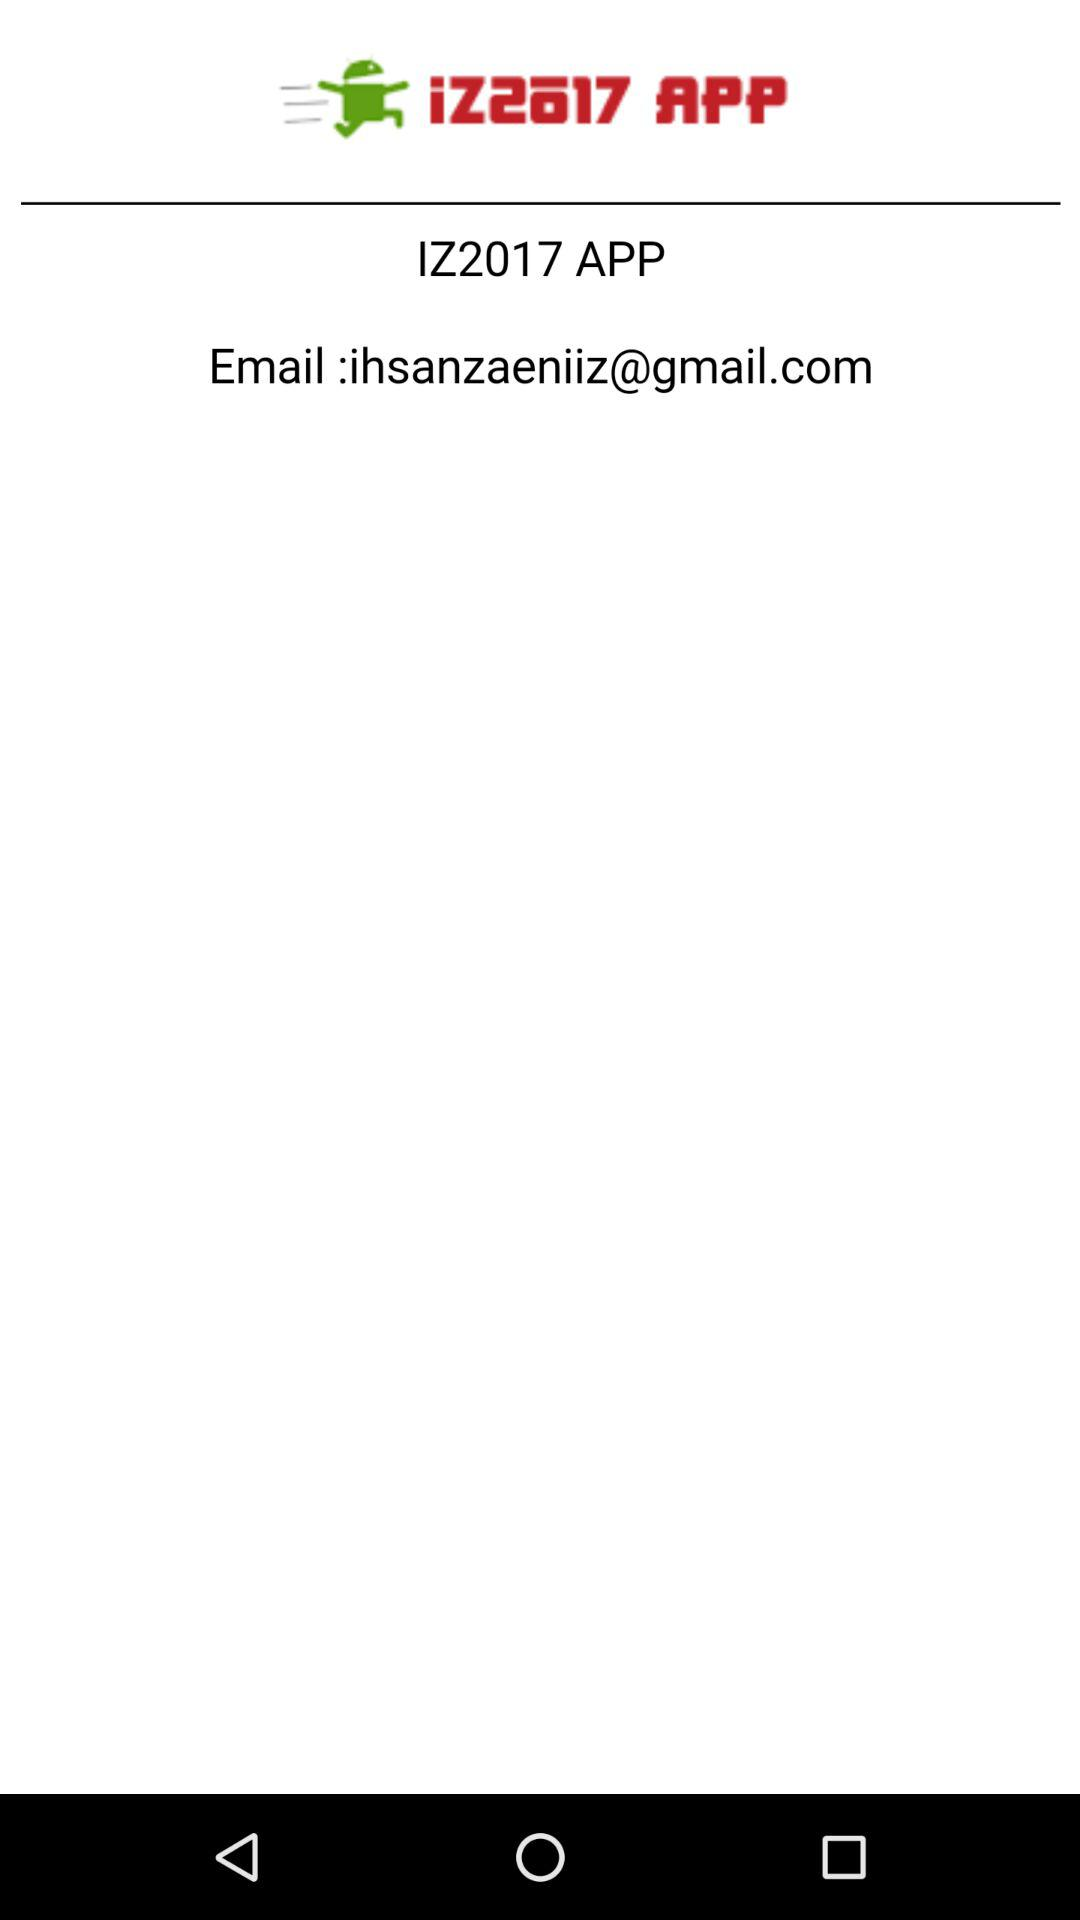Who does this email belong to?
When the provided information is insufficient, respond with <no answer>. <no answer> 